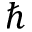<formula> <loc_0><loc_0><loc_500><loc_500>\hbar</formula> 